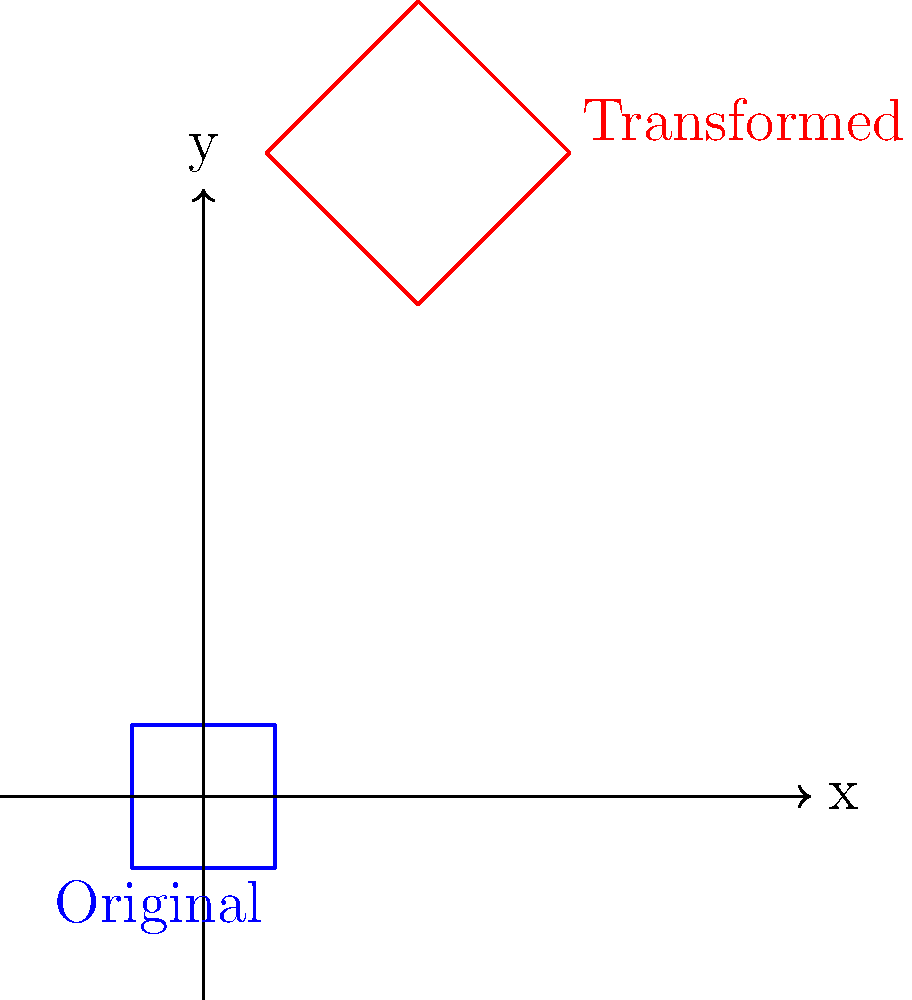As a museum curator, you've discovered a transformed native cave painting. The original painting was a square with side length 1 unit, centered at the origin. The transformed painting has been rotated 45°, scaled by a factor of 1.5, and translated 2 units right and 1 unit up. What is the area of the transformed painting? To find the area of the transformed painting, we need to follow these steps:

1. Determine the area of the original painting:
   - The original is a square with side length 1 unit
   - Area of a square = side length squared
   - Original area = $1^2 = 1$ square unit

2. Identify the transformations applied:
   - Rotation: 45° (this doesn't affect the area)
   - Scaling: factor of 1.5
   - Translation: 2 units right and 1 unit up (this doesn't affect the area)

3. Calculate the effect of scaling on the area:
   - When a shape is scaled by a factor $k$, its area is multiplied by $k^2$
   - Scaling factor = 1.5
   - Area scale factor = $1.5^2 = 2.25$

4. Calculate the final area:
   - Transformed area = Original area × Area scale factor
   - Transformed area = $1 \times 2.25 = 2.25$ square units

Therefore, the area of the transformed cave painting is 2.25 square units.
Answer: 2.25 square units 